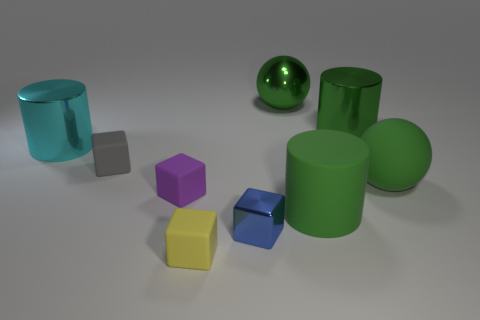Subtract all purple matte cubes. How many cubes are left? 3 Add 1 purple matte cubes. How many objects exist? 10 Subtract all cyan cylinders. How many cylinders are left? 2 Subtract all blocks. How many objects are left? 5 Subtract 1 cubes. How many cubes are left? 3 Subtract all purple blocks. How many blue balls are left? 0 Add 6 large cyan things. How many large cyan things are left? 7 Add 7 large green rubber balls. How many large green rubber balls exist? 8 Subtract 0 brown blocks. How many objects are left? 9 Subtract all cyan spheres. Subtract all yellow blocks. How many spheres are left? 2 